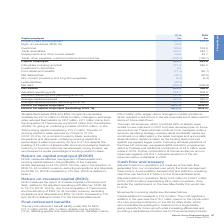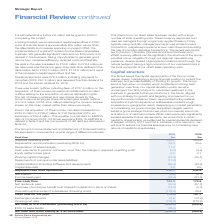According to Spirax Sarco Engineering Plc's financial document, What is the amount of dividend payments in 2019? According to the financial document, £76.3 million. The relevant text states: "Dividend payments were £76.3 million, including payments to minorities (2018: £67.3 million) and represent the final dividend for 2018 a..." Also, What led to the increase in net debt in 2019? the acquisition of Thermocoax. The document states: "ed assets by £8.3 million, £8.1 million came from the acquisition of Thermocoax and £40.8 million from the adoption of IFRS 16, giving an underlying i..." Also, What was the  Net debt and lease liability at 31st December for 2018 and 2019 respectively? The document shows two values: (334.1) and (235.8) (in millions). From the document: ".1 Exchange movements 13.6 (13.3) Opening net debt (235.8) (373.6) Net debt at 31st December (excluding IFRS 16) (295.2) (235.8) IFRS 16 lease liabili..." Additionally, In which year was the amount of Depreciation and amortisation (excluding IFRS 16) larger? According to the financial document, 2019. The relevant text states: "Annual Report 2019..." Also, can you calculate: What was the change in free cash flow in 2019 from 2018? Based on the calculation: 154.3-174.6, the result is -20.3 (in millions). This is based on the information: "7) Income taxes paid (78.4) (61.6) Free cash flow 154.3 174.6 Net dividends paid (76.3) (67.3) Purchase of employee benefit trust shares/Proceeds from issu ome taxes paid (78.4) (61.6) Free cash flow ..." The key data points involved are: 154.3, 174.6. Also, can you calculate: What was the percentage change in free cash flow in 2019 from 2018? To answer this question, I need to perform calculations using the financial data. The calculation is: (154.3-174.6)/174.6, which equals -11.63 (percentage). This is based on the information: "7) Income taxes paid (78.4) (61.6) Free cash flow 154.3 174.6 Net dividends paid (76.3) (67.3) Purchase of employee benefit trust shares/Proceeds from issu ome taxes paid (78.4) (61.6) Free cash flow ..." The key data points involved are: 154.3, 174.6. 